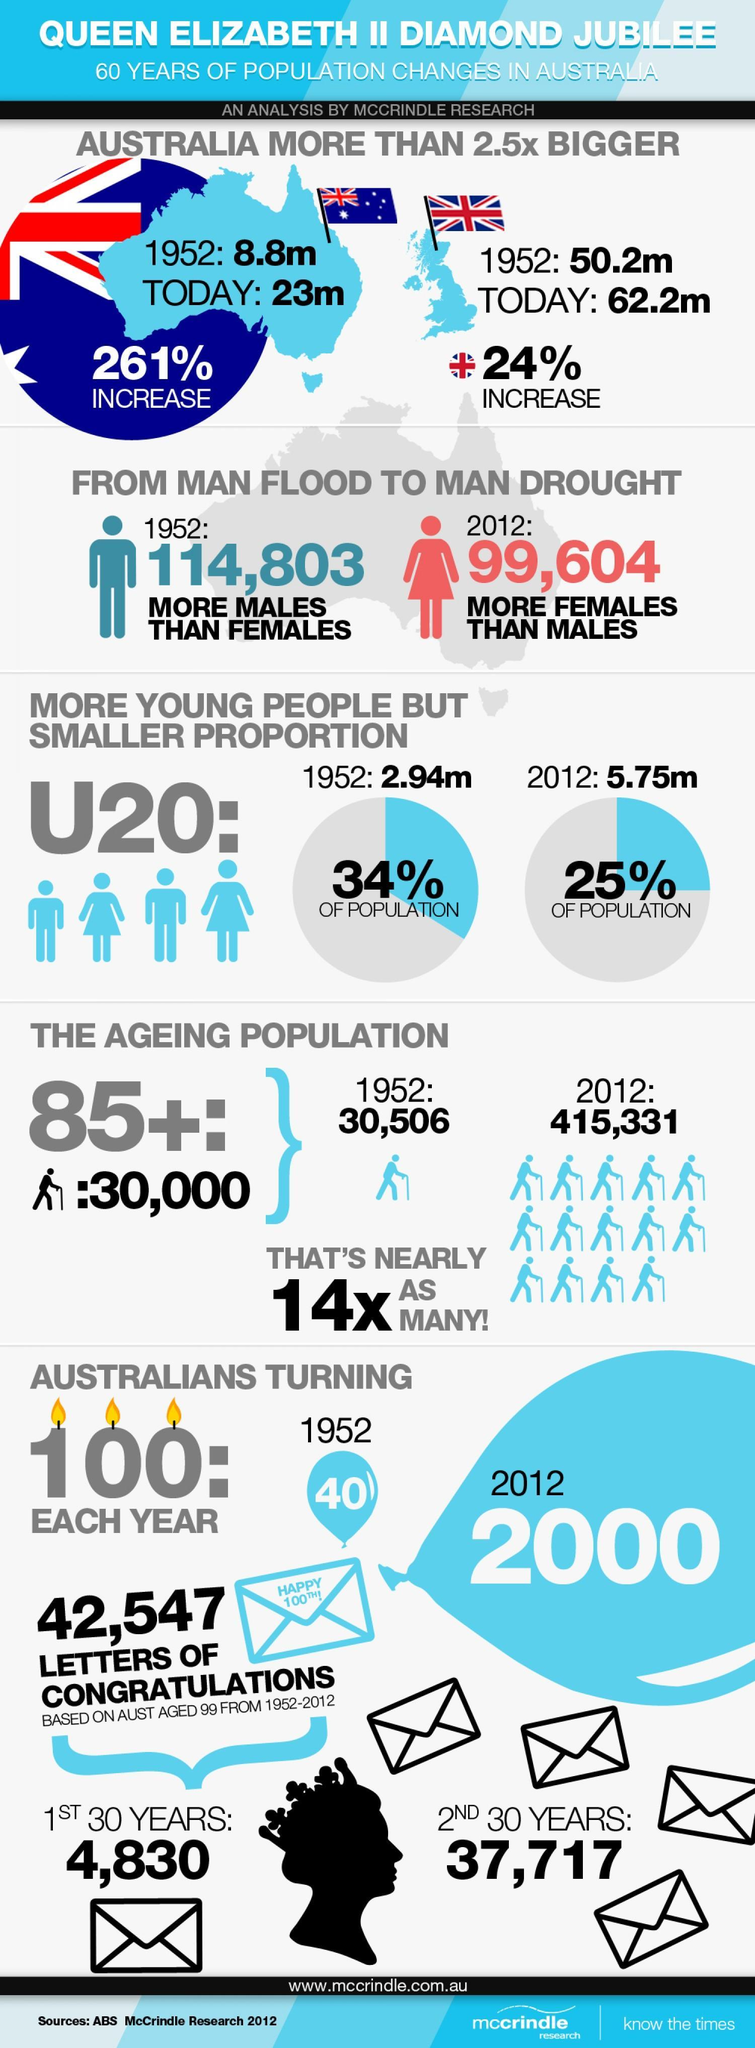how many people turned centenarians in 2012
Answer the question with a short phrase. 2000 what has been the population increase in UK from 1952 to today 24% what is the under 20 population percentage in 2012 25% what is the 85+ ageing population 30,000 When was the female population more than males 2012 how many people turned centenarians in 1952 40 how many times has the ageing population increased in 60 years 14X what has been the population increase in Australia from 1952 to today 261% how much percentage has the under 20 population reduced in 60 years 9 